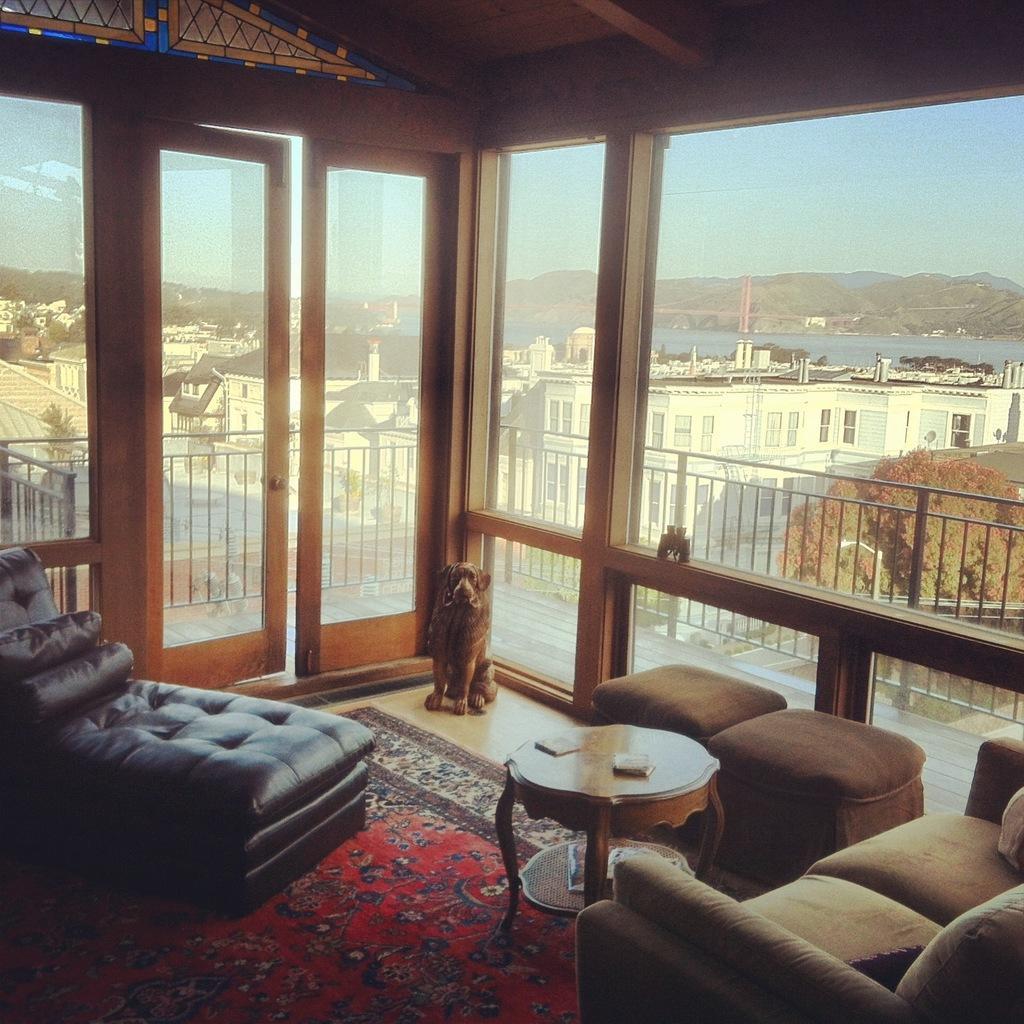Could you give a brief overview of what you see in this image? In the image we can see there is a dog in a room and there are chairs and sofa and at the back there are buildings. 